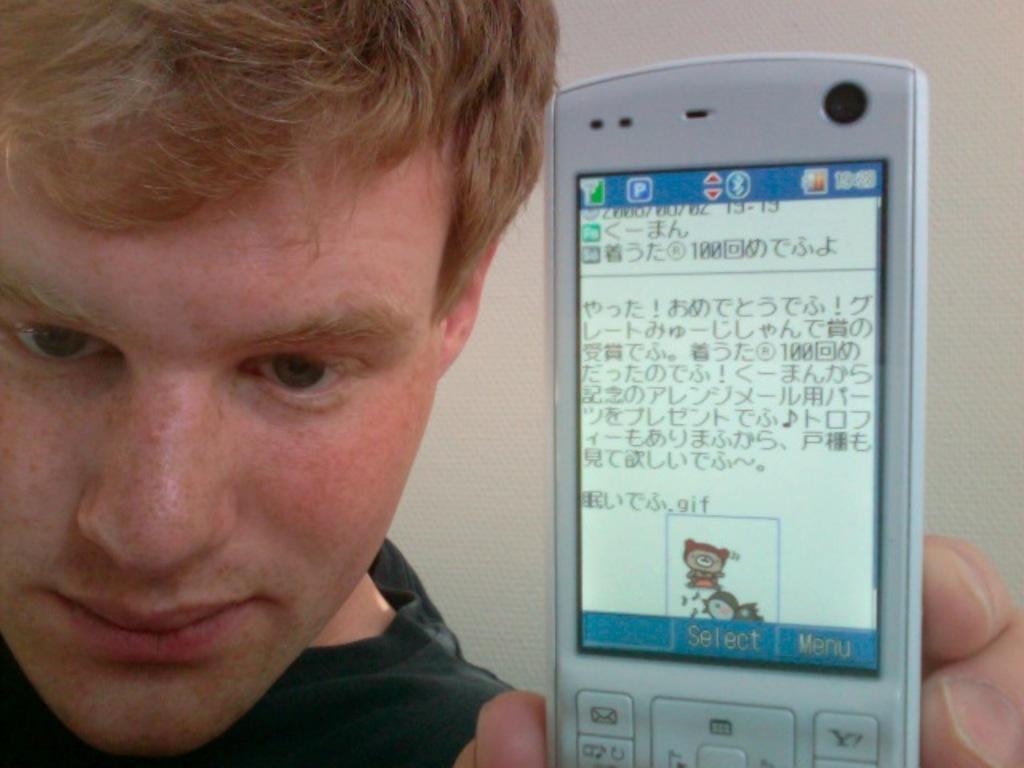In one or two sentences, can you explain what this image depicts? In this picture there is a man who is looking down and he is holding a mobile phone with some data and displaying it and in the background there is a white colour wall and there some buttons on the mobile 